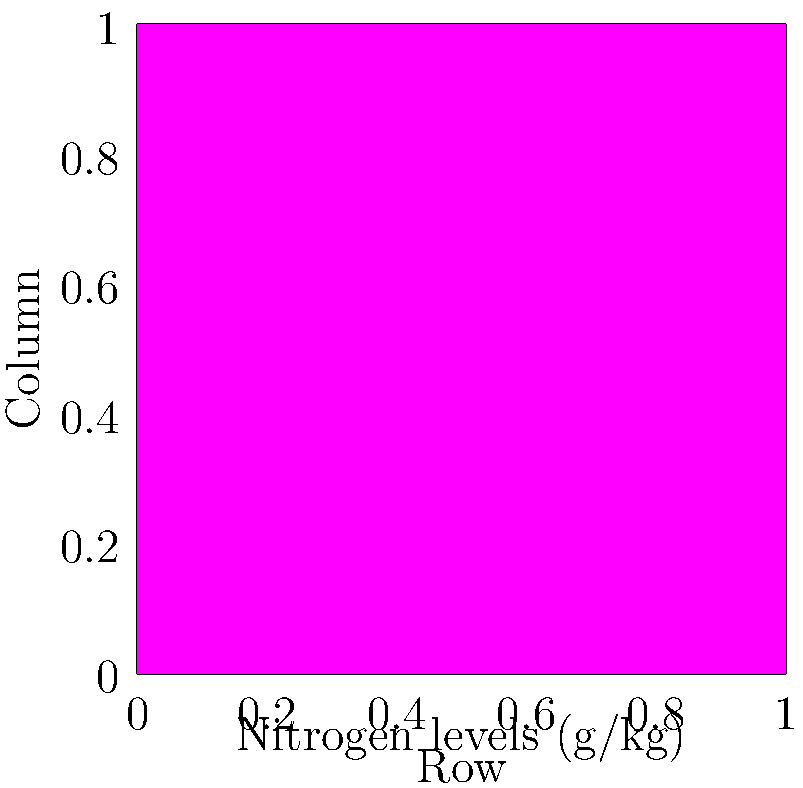Based on the heat map representing nitrogen levels (g/kg) in a vineyard, which quadrant of the vineyard shows the highest concentration of nitrogen, and what strategy would you recommend to address potential nutrient imbalances? To answer this question, we need to analyze the heat map and interpret the data:

1. Observe the color gradient: The heat map uses a rainbow color scheme where red represents higher values and blue represents lower values.

2. Identify the highest concentration area:
   - The top-right corner (upper-right quadrant) shows the darkest red color.
   - This indicates the highest nitrogen concentration in the vineyard.

3. Interpret the legend:
   - The color bar on the right shows that the darkest red corresponds to approximately 4.8 g/kg of nitrogen.

4. Analyze the nutrient distribution:
   - There's a clear gradient from the bottom-left (lowest concentration) to the top-right (highest concentration).
   - This suggests an uneven distribution of nitrogen across the vineyard.

5. Recommend a strategy:
   - To address the nutrient imbalance, a site-specific fertilization approach, known as precision viticulture, would be most effective.
   - This involves applying less nitrogen to the top-right quadrant and more to the bottom-left quadrant.
   - The goal is to achieve a more uniform nitrogen distribution across the vineyard.

6. Additional considerations:
   - Investigate the cause of the imbalance (e.g., soil type variations, topography, or previous management practices).
   - Consider the optimal nitrogen levels for the specific grape variety and desired wine style.
   - Implement soil testing and leaf tissue analysis to fine-tune the fertilization strategy.
Answer: Top-right quadrant; implement precision viticulture with site-specific fertilization to balance nitrogen levels across the vineyard. 